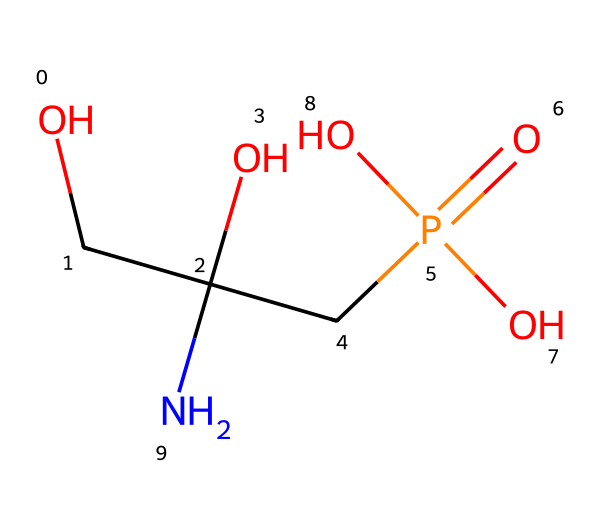What is the functional group present in glyphosate? Glyphosate contains an amine functional group indicated by the nitrogen atom bonded to a carbon chain. Additionally, it has a phosphate group represented by the P(=O)(O)O structure.
Answer: amine and phosphate How many carbon atoms are in glyphosate? By analyzing the chemical structure, we identify four carbon atoms present in the overall molecular framework.
Answer: four What type of herbicide is glyphosate classified as? Glyphosate is classified as a broad-spectrum herbicide because it is effective against a wide variety of plants, disrupting amino acid synthesis in invasive species.
Answer: broad-spectrum What is the total number of oxygen atoms present in glyphosate? Inspecting the chemical structure, we find that there are five oxygen atoms connected to various parts of the molecule, including the phosphate group and hydroxyl groups.
Answer: five How does the presence of the phosphate group affect the solubility of glyphosate? The phosphate group, being polar and hydrophilic, increases glyphosate’s solubility in water compared to non-polar compounds, facilitating its application as a herbicide.
Answer: increases solubility Can glyphosate be considered an organophosphate? Although glyphosate contains a phosphate group, it does not function as an organophosphate because organophosphates primarily refer to insecticides affecting the nervous system, while glyphosate acts as a herbicide targeting plant biochemistry.
Answer: no What is the molecular weight of glyphosate? By adding the atomic weights of all atoms present in the SMILES representation, the molecular weight of glyphosate calculates approximately to 169.07 g/mol.
Answer: 169.07 g/mol 